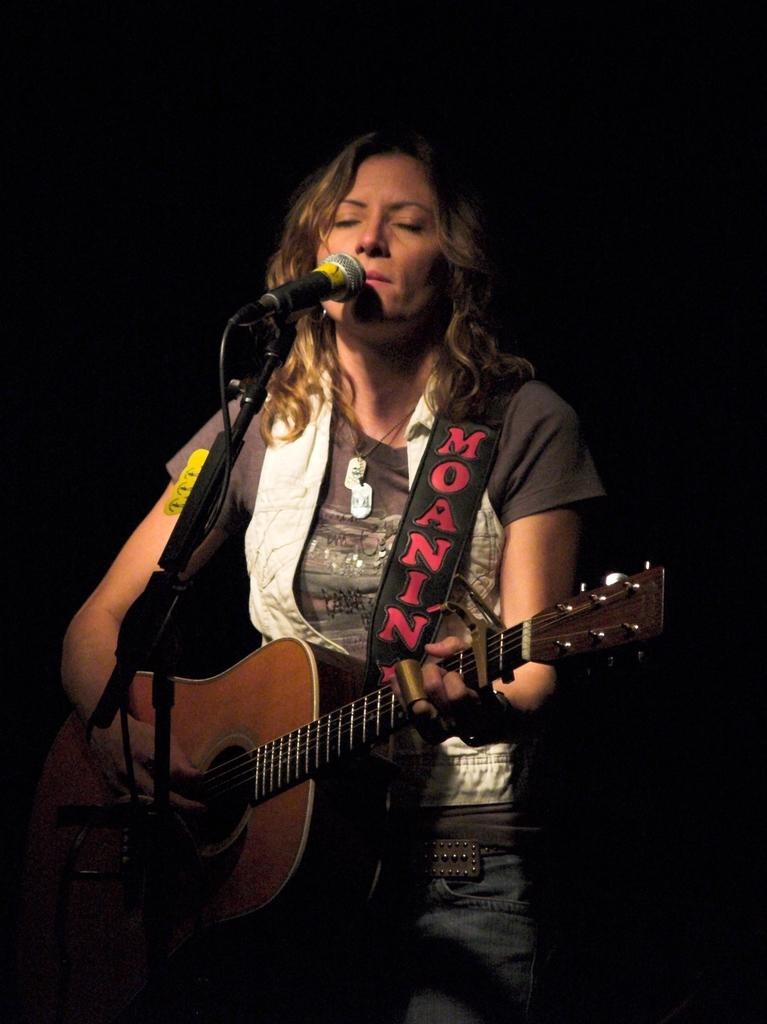What is the main subject of the image? The main subject of the image is a woman. What is the woman doing in the image? The woman is singing and playing a guitar. What object is in front of the woman? There is a microphone in front of the woman. What type of camera is the woman using to take pictures in the image? There is no camera present in the image, and the woman is not taking pictures; she is singing and playing a guitar. Is the woman a representative of a particular organization in the image? There is no information provided about the woman's affiliations or roles, so it cannot be determined if she is a representative of any organization. 